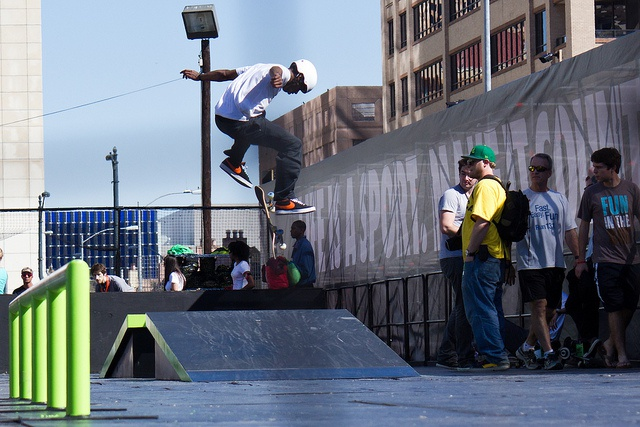Describe the objects in this image and their specific colors. I can see people in lightgray, black, and teal tones, people in lightgray, black, white, and blue tones, people in lightgray, black, navy, and gray tones, people in lightgray, black, navy, olive, and khaki tones, and people in lightgray, black, navy, and gray tones in this image. 